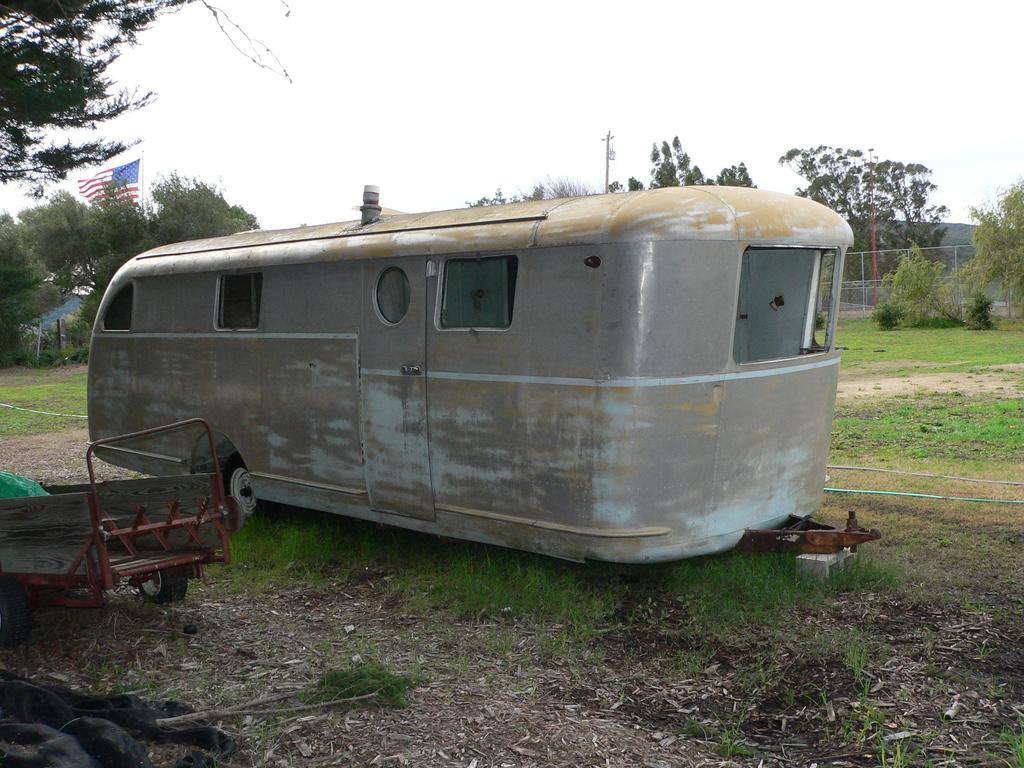Could you give a brief overview of what you see in this image? This image is clicked outside. There are trees in the middle. There is sky at the top. There is the flag on the left side. There is a vehicle in the middle. 